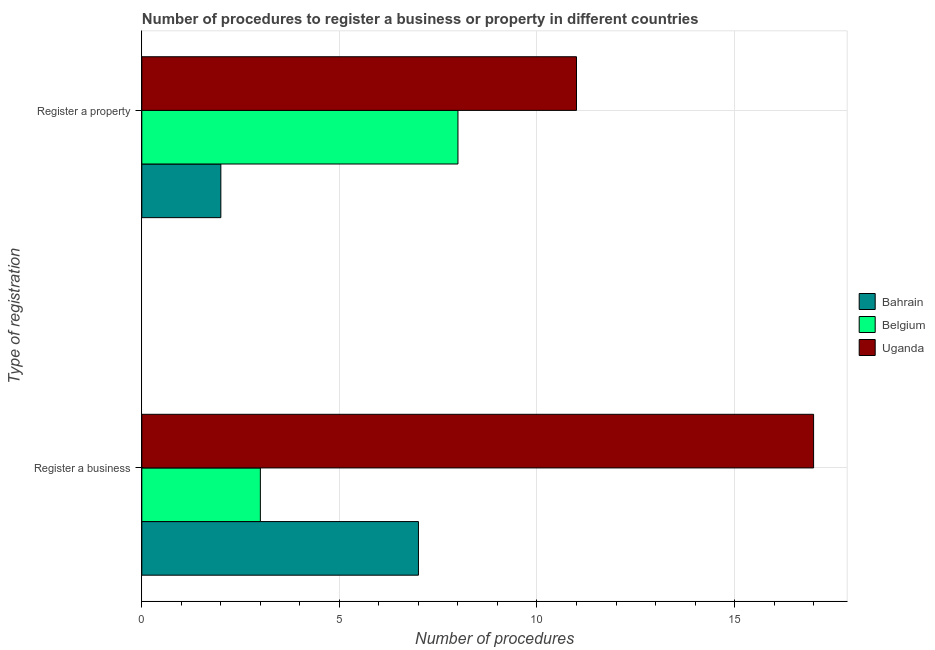How many groups of bars are there?
Keep it short and to the point. 2. Are the number of bars on each tick of the Y-axis equal?
Provide a short and direct response. Yes. How many bars are there on the 2nd tick from the bottom?
Give a very brief answer. 3. What is the label of the 1st group of bars from the top?
Give a very brief answer. Register a property. What is the number of procedures to register a property in Belgium?
Ensure brevity in your answer.  8. Across all countries, what is the maximum number of procedures to register a business?
Your answer should be very brief. 17. Across all countries, what is the minimum number of procedures to register a property?
Your response must be concise. 2. In which country was the number of procedures to register a property maximum?
Provide a short and direct response. Uganda. In which country was the number of procedures to register a property minimum?
Offer a terse response. Bahrain. What is the total number of procedures to register a business in the graph?
Provide a succinct answer. 27. What is the difference between the number of procedures to register a business in Uganda and that in Belgium?
Offer a very short reply. 14. What is the difference between the number of procedures to register a property in Belgium and the number of procedures to register a business in Bahrain?
Your response must be concise. 1. What is the average number of procedures to register a business per country?
Your answer should be compact. 9. What is the difference between the number of procedures to register a property and number of procedures to register a business in Belgium?
Give a very brief answer. 5. What is the ratio of the number of procedures to register a property in Uganda to that in Belgium?
Offer a terse response. 1.38. Is the number of procedures to register a property in Uganda less than that in Belgium?
Give a very brief answer. No. In how many countries, is the number of procedures to register a property greater than the average number of procedures to register a property taken over all countries?
Give a very brief answer. 2. What does the 3rd bar from the top in Register a business represents?
Offer a very short reply. Bahrain. What does the 1st bar from the bottom in Register a business represents?
Your answer should be compact. Bahrain. How many bars are there?
Offer a terse response. 6. Are the values on the major ticks of X-axis written in scientific E-notation?
Your response must be concise. No. Does the graph contain any zero values?
Offer a very short reply. No. Does the graph contain grids?
Your response must be concise. Yes. How many legend labels are there?
Make the answer very short. 3. How are the legend labels stacked?
Your answer should be very brief. Vertical. What is the title of the graph?
Your answer should be compact. Number of procedures to register a business or property in different countries. What is the label or title of the X-axis?
Offer a terse response. Number of procedures. What is the label or title of the Y-axis?
Give a very brief answer. Type of registration. Across all Type of registration, what is the maximum Number of procedures of Bahrain?
Offer a very short reply. 7. Across all Type of registration, what is the maximum Number of procedures in Belgium?
Offer a very short reply. 8. Across all Type of registration, what is the maximum Number of procedures in Uganda?
Keep it short and to the point. 17. What is the total Number of procedures in Bahrain in the graph?
Provide a succinct answer. 9. What is the total Number of procedures of Belgium in the graph?
Your answer should be very brief. 11. What is the total Number of procedures of Uganda in the graph?
Your response must be concise. 28. What is the difference between the Number of procedures of Bahrain in Register a business and that in Register a property?
Your answer should be compact. 5. What is the difference between the Number of procedures of Belgium in Register a business and that in Register a property?
Give a very brief answer. -5. What is the difference between the Number of procedures in Uganda in Register a business and that in Register a property?
Ensure brevity in your answer.  6. What is the difference between the Number of procedures in Bahrain in Register a business and the Number of procedures in Belgium in Register a property?
Keep it short and to the point. -1. What is the average Number of procedures in Belgium per Type of registration?
Your answer should be very brief. 5.5. What is the difference between the Number of procedures of Bahrain and Number of procedures of Uganda in Register a business?
Give a very brief answer. -10. What is the difference between the Number of procedures of Belgium and Number of procedures of Uganda in Register a business?
Offer a terse response. -14. What is the ratio of the Number of procedures of Uganda in Register a business to that in Register a property?
Offer a very short reply. 1.55. What is the difference between the highest and the second highest Number of procedures of Bahrain?
Your answer should be compact. 5. What is the difference between the highest and the lowest Number of procedures of Bahrain?
Provide a succinct answer. 5. What is the difference between the highest and the lowest Number of procedures in Belgium?
Provide a succinct answer. 5. What is the difference between the highest and the lowest Number of procedures in Uganda?
Provide a succinct answer. 6. 